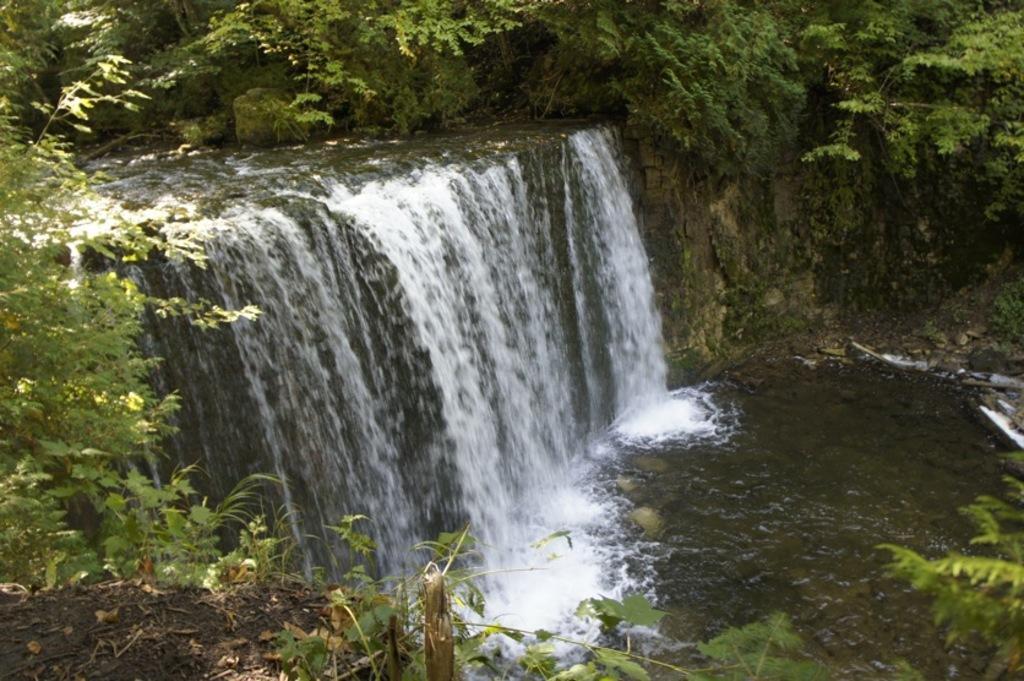How would you summarize this image in a sentence or two? In this picture there is a waterfall and there are trees. At the bottom there is water. In the foreground there is mud. 